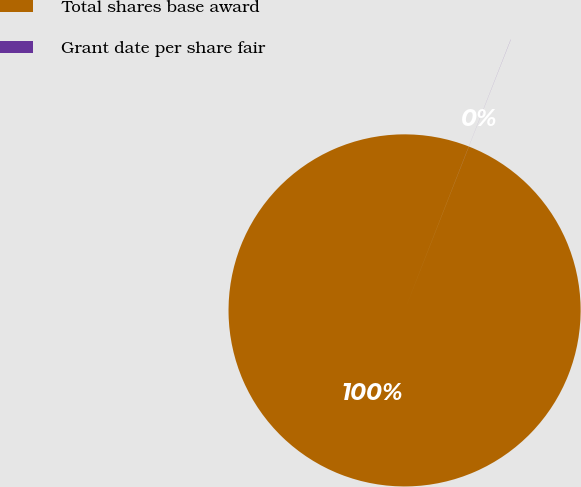Convert chart. <chart><loc_0><loc_0><loc_500><loc_500><pie_chart><fcel>Total shares base award<fcel>Grant date per share fair<nl><fcel>99.99%<fcel>0.01%<nl></chart> 